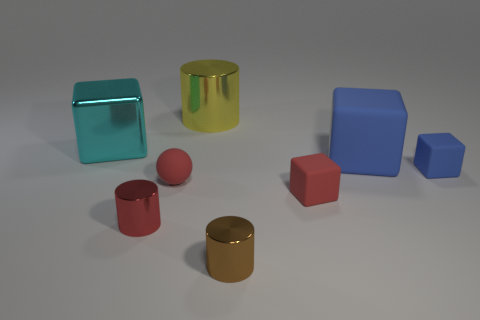Is the number of red metal objects right of the small brown metal thing the same as the number of big cyan metallic cylinders?
Offer a terse response. Yes. Does the cyan cube have the same size as the brown shiny thing?
Make the answer very short. No. There is a small shiny object that is left of the tiny shiny cylinder to the right of the matte sphere; are there any metallic cylinders that are behind it?
Offer a terse response. Yes. There is another big object that is the same shape as the big cyan metallic thing; what is it made of?
Provide a short and direct response. Rubber. There is a metal cylinder that is to the left of the large shiny cylinder; what number of metal blocks are right of it?
Provide a succinct answer. 0. What size is the red matte object on the right side of the metal cylinder right of the yellow shiny thing to the left of the red block?
Offer a very short reply. Small. What color is the thing on the left side of the red cylinder that is in front of the big shiny block?
Your answer should be very brief. Cyan. How many other objects are there of the same material as the big blue thing?
Your answer should be compact. 3. How many other objects are there of the same color as the metal cube?
Provide a short and direct response. 0. What material is the cylinder that is behind the tiny rubber block in front of the tiny blue rubber thing made of?
Make the answer very short. Metal. 